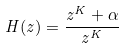<formula> <loc_0><loc_0><loc_500><loc_500>H ( z ) = \frac { z ^ { K } + \alpha } { z ^ { K } }</formula> 